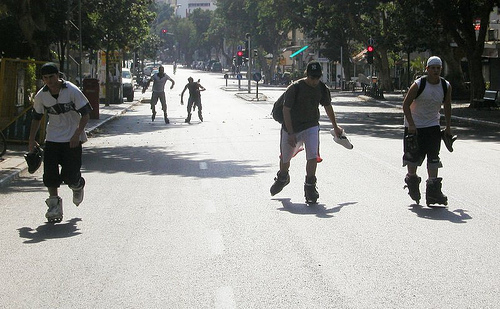How do the roller blades these people are wearing compare to traditional roller skates in terms of maneuverability? Roller blades, which have wheels aligned in a single row, offer greater maneuverability compared to traditional roller skates. Their design allows for tighter turns and more precision when skating at higher speeds, making them a popular choice for street skating and various inline sports. 